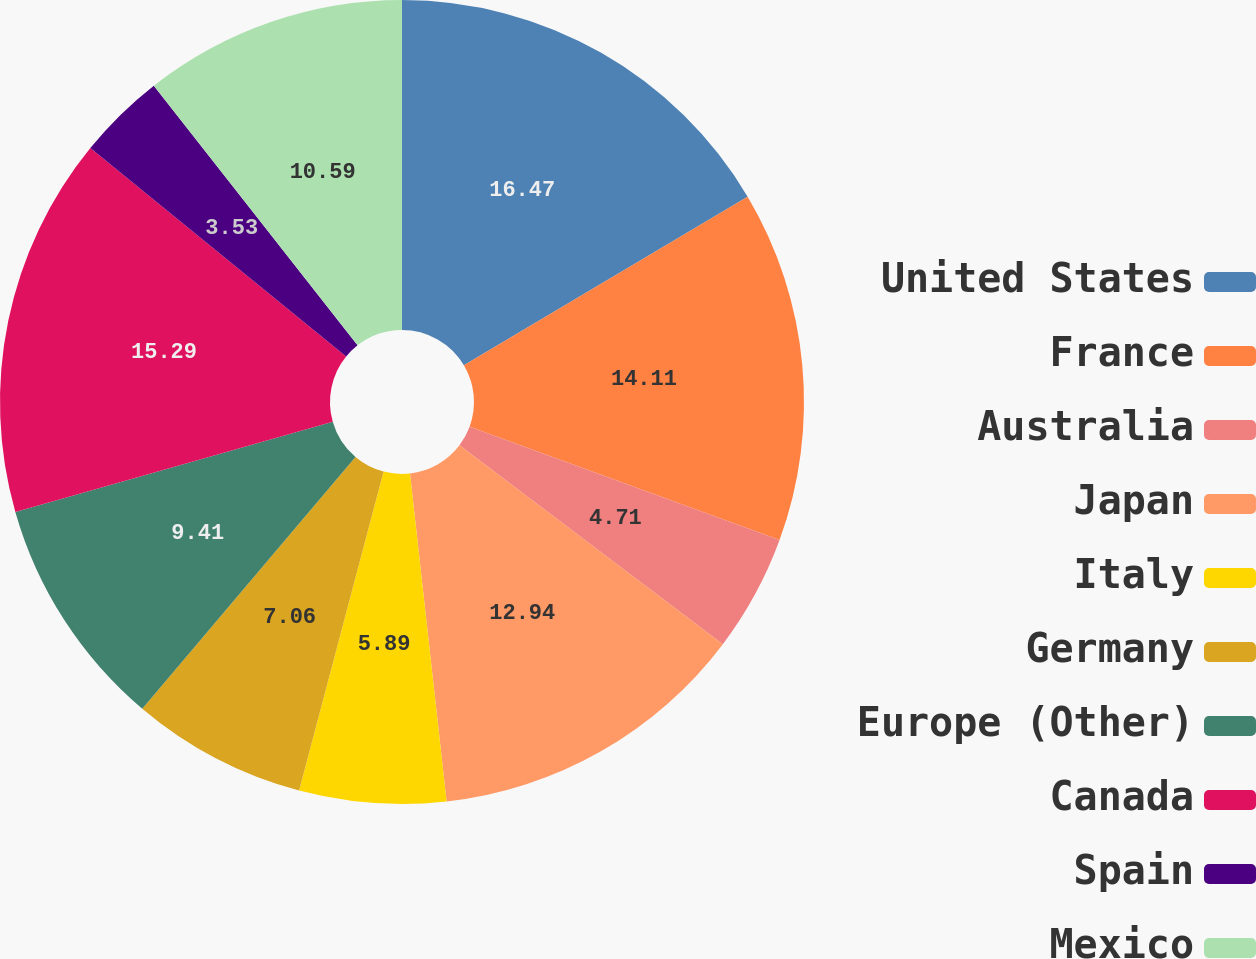Convert chart. <chart><loc_0><loc_0><loc_500><loc_500><pie_chart><fcel>United States<fcel>France<fcel>Australia<fcel>Japan<fcel>Italy<fcel>Germany<fcel>Europe (Other)<fcel>Canada<fcel>Spain<fcel>Mexico<nl><fcel>16.47%<fcel>14.11%<fcel>4.71%<fcel>12.94%<fcel>5.89%<fcel>7.06%<fcel>9.41%<fcel>15.29%<fcel>3.53%<fcel>10.59%<nl></chart> 